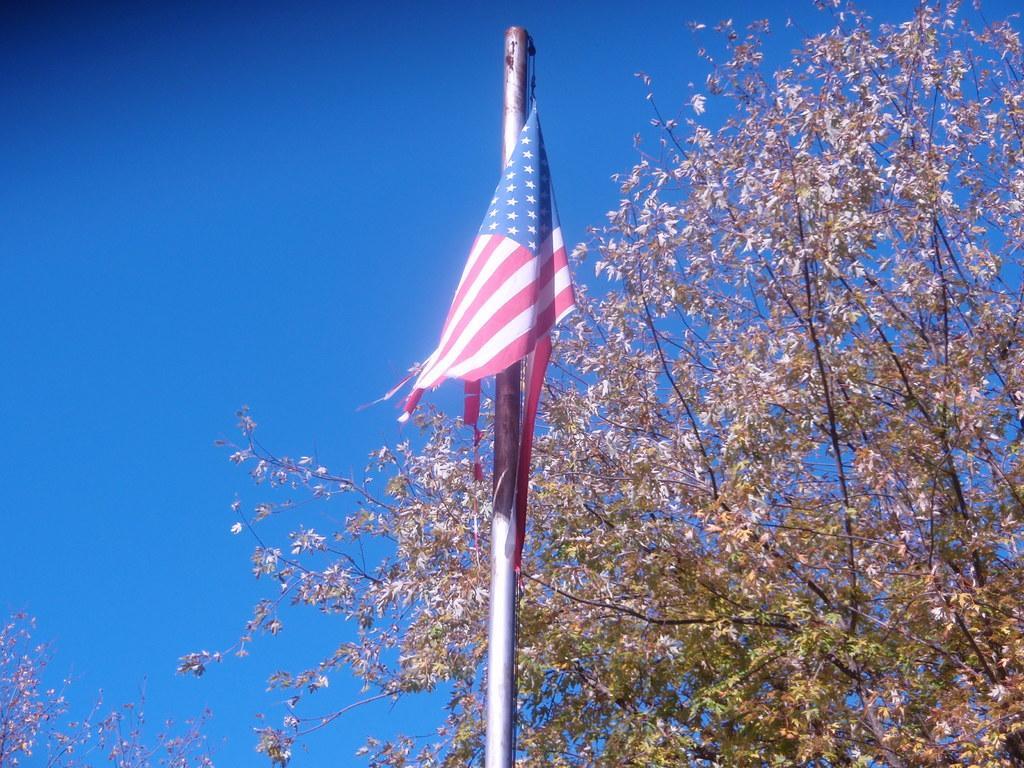Can you describe this image briefly? In the image we can see a flag of a country, this is a pole, tree and a sky. 